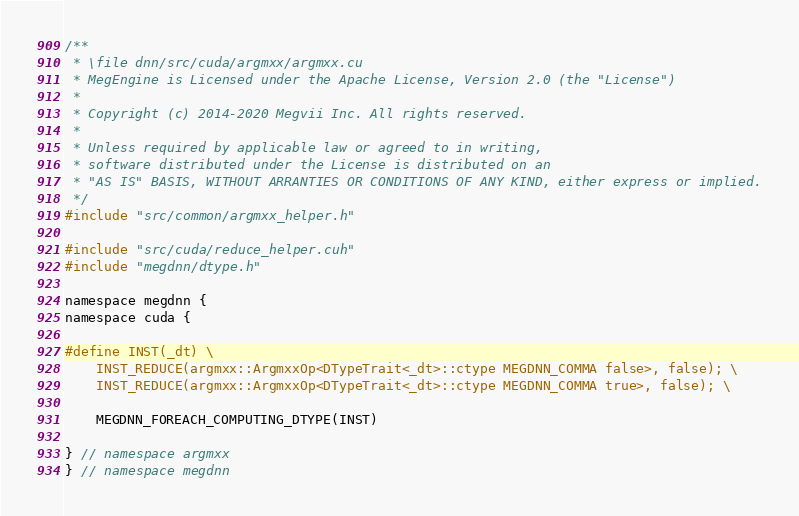<code> <loc_0><loc_0><loc_500><loc_500><_Cuda_>/**
 * \file dnn/src/cuda/argmxx/argmxx.cu
 * MegEngine is Licensed under the Apache License, Version 2.0 (the "License")
 *
 * Copyright (c) 2014-2020 Megvii Inc. All rights reserved.
 *
 * Unless required by applicable law or agreed to in writing,
 * software distributed under the License is distributed on an
 * "AS IS" BASIS, WITHOUT ARRANTIES OR CONDITIONS OF ANY KIND, either express or implied.
 */
#include "src/common/argmxx_helper.h"

#include "src/cuda/reduce_helper.cuh"
#include "megdnn/dtype.h"

namespace megdnn {
namespace cuda {

#define INST(_dt) \
    INST_REDUCE(argmxx::ArgmxxOp<DTypeTrait<_dt>::ctype MEGDNN_COMMA false>, false); \
    INST_REDUCE(argmxx::ArgmxxOp<DTypeTrait<_dt>::ctype MEGDNN_COMMA true>, false); \

    MEGDNN_FOREACH_COMPUTING_DTYPE(INST)

} // namespace argmxx
} // namespace megdnn
</code> 